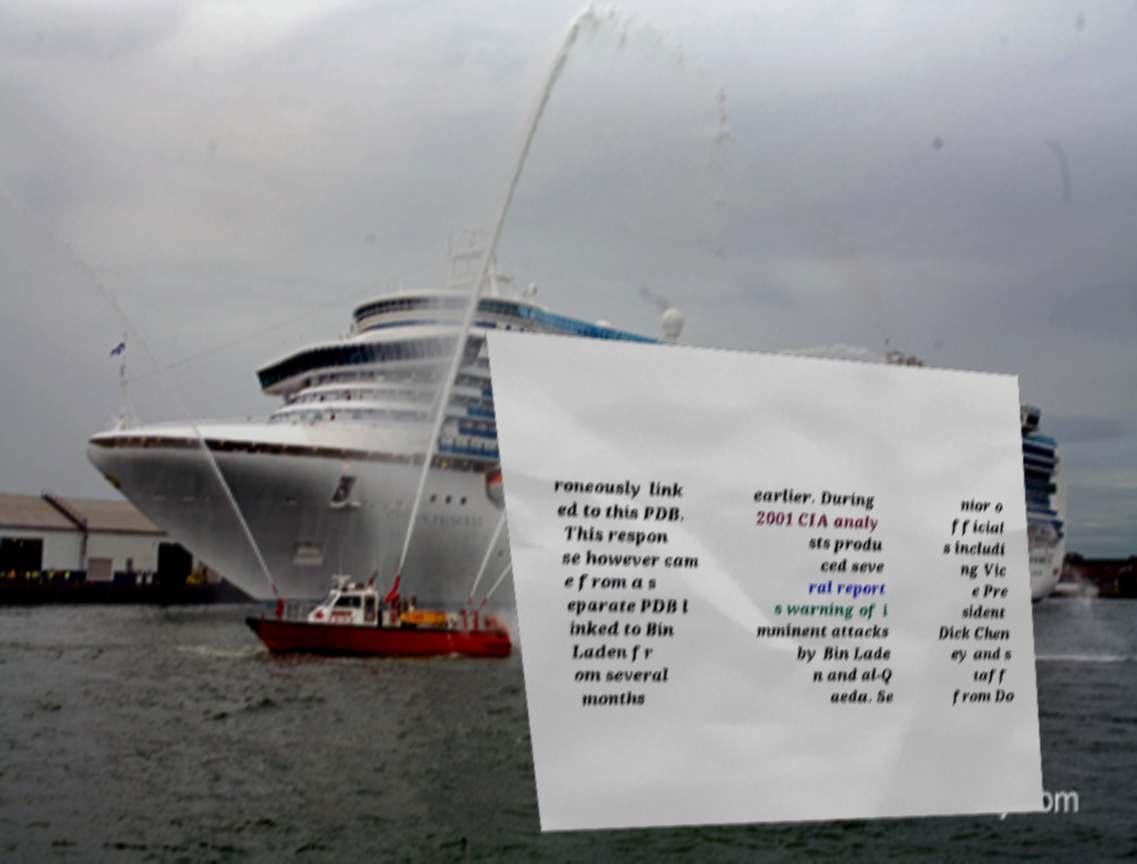Could you assist in decoding the text presented in this image and type it out clearly? roneously link ed to this PDB. This respon se however cam e from a s eparate PDB l inked to Bin Laden fr om several months earlier. During 2001 CIA analy sts produ ced seve ral report s warning of i mminent attacks by Bin Lade n and al-Q aeda. Se nior o fficial s includi ng Vic e Pre sident Dick Chen ey and s taff from Do 